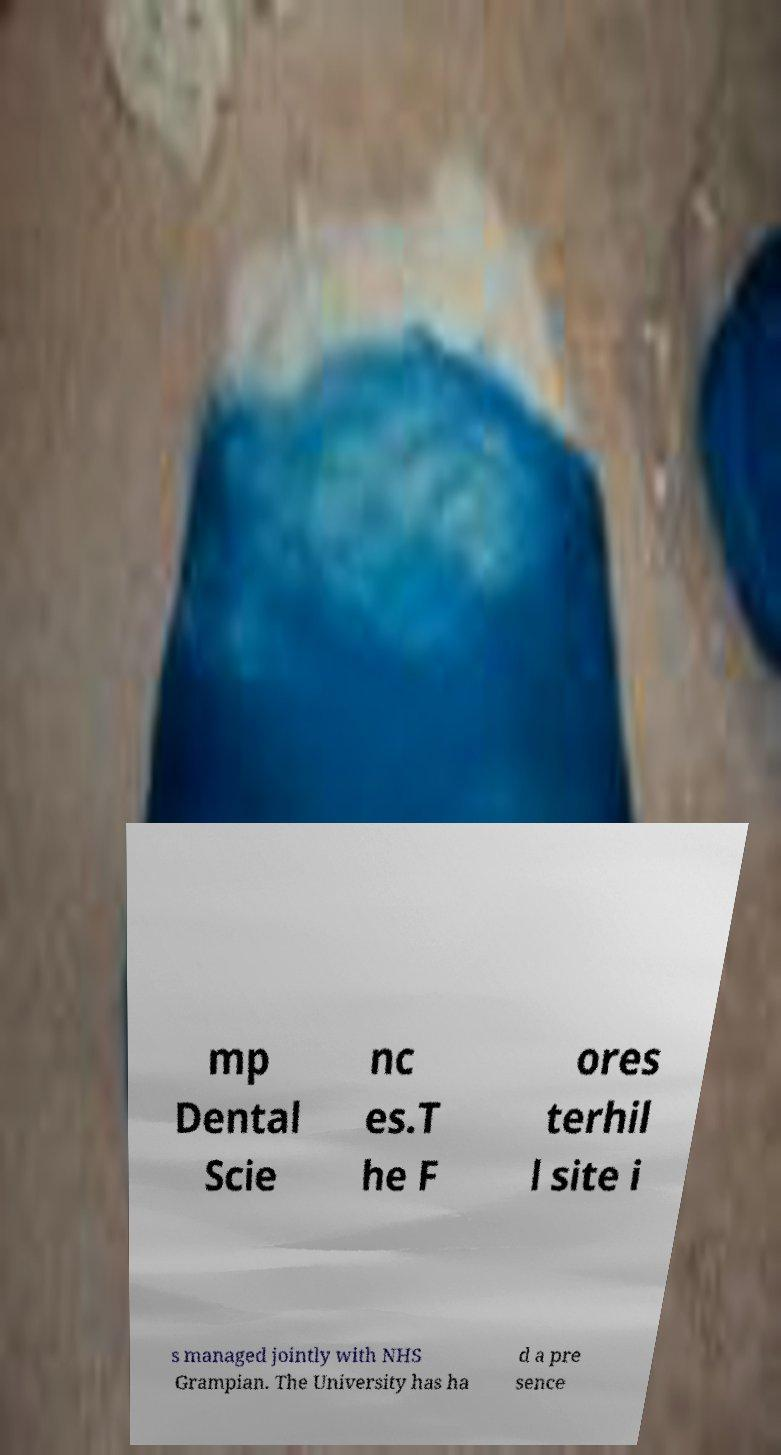For documentation purposes, I need the text within this image transcribed. Could you provide that? mp Dental Scie nc es.T he F ores terhil l site i s managed jointly with NHS Grampian. The University has ha d a pre sence 